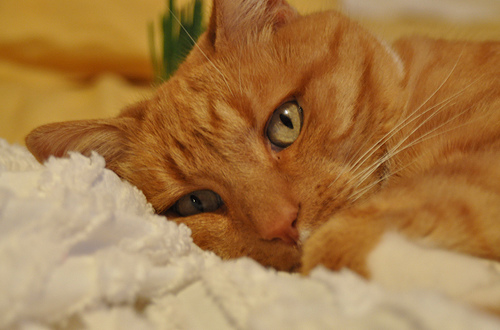<image>What breed of cat is it? I don't know what breed of cat it is. It could be a tabby, Siberian, sphinx, or American shorthair. What breed of cat is it? I am not sure what breed of cat it is. It can be seen as 'tabby', 'siberian', 'tom', 'sphinx' or 'american shorthair'. 